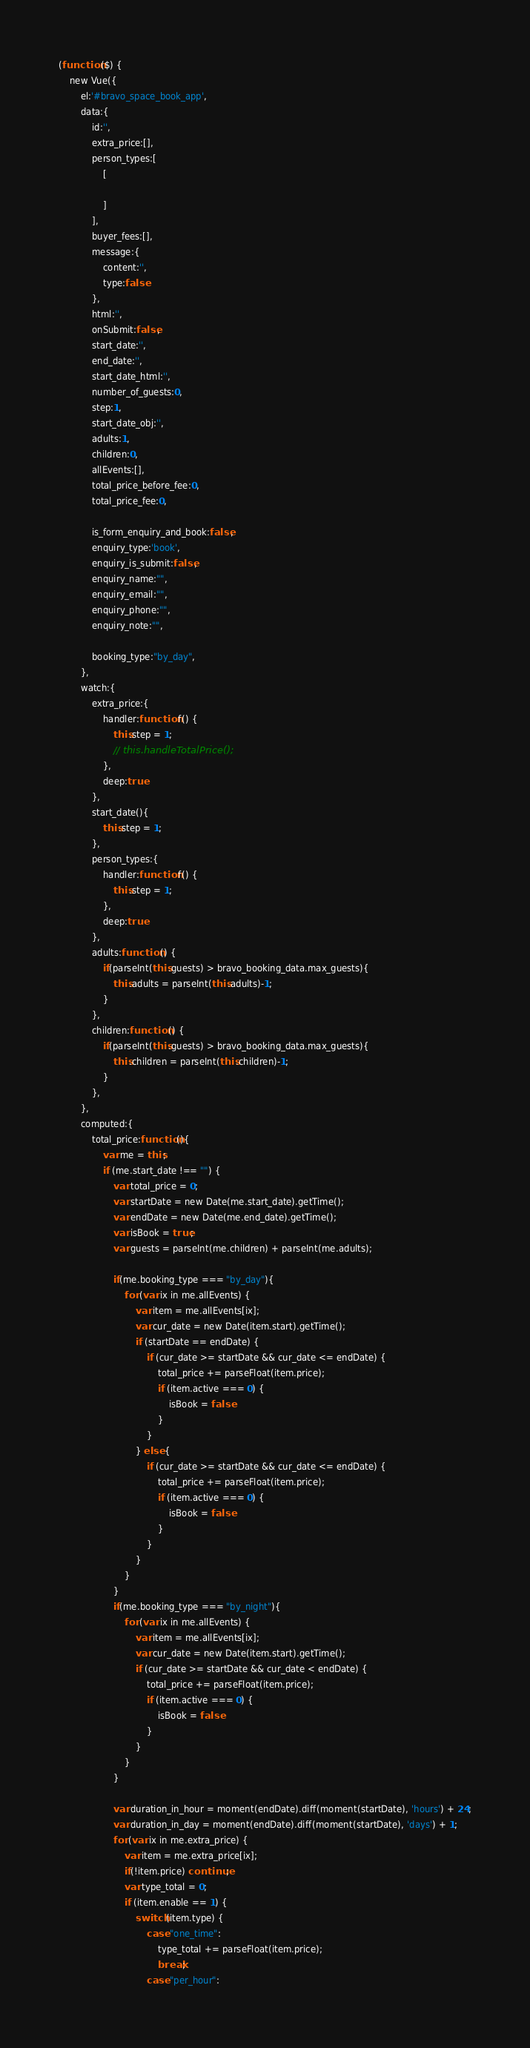Convert code to text. <code><loc_0><loc_0><loc_500><loc_500><_JavaScript_>(function ($) {
    new Vue({
        el:'#bravo_space_book_app',
        data:{
            id:'',
            extra_price:[],
            person_types:[
                [

                ]
            ],
            buyer_fees:[],
            message:{
                content:'',
                type:false
            },
            html:'',
            onSubmit:false,
            start_date:'',
            end_date:'',
            start_date_html:'',
            number_of_guests:0,
            step:1,
            start_date_obj:'',
            adults:1,
            children:0,
            allEvents:[],
            total_price_before_fee:0,
            total_price_fee:0,

            is_form_enquiry_and_book:false,
            enquiry_type:'book',
            enquiry_is_submit:false,
            enquiry_name:"",
            enquiry_email:"",
            enquiry_phone:"",
            enquiry_note:"",

            booking_type:"by_day",
        },
        watch:{
            extra_price:{
                handler:function f() {
                    this.step = 1;
                    // this.handleTotalPrice();
                },
                deep:true
            },
            start_date(){
                this.step = 1;
            },
            person_types:{
                handler:function f() {
                    this.step = 1;
                },
                deep:true
            },
            adults:function () {
                if(parseInt(this.guests) > bravo_booking_data.max_guests){
                    this.adults = parseInt(this.adults)-1;
                }
            },
            children:function () {
                if(parseInt(this.guests) > bravo_booking_data.max_guests){
                    this.children = parseInt(this.children)-1;
                }
            },
        },
        computed:{
            total_price:function(){
                var me = this;
                if (me.start_date !== "") {
                    var total_price = 0;
                    var startDate = new Date(me.start_date).getTime();
                    var endDate = new Date(me.end_date).getTime();
                    var isBook = true;
                    var guests = parseInt(me.children) + parseInt(me.adults);

                    if(me.booking_type === "by_day"){
                        for (var ix in me.allEvents) {
                            var item = me.allEvents[ix];
                            var cur_date = new Date(item.start).getTime();
                            if (startDate == endDate) {
                                if (cur_date >= startDate && cur_date <= endDate) {
                                    total_price += parseFloat(item.price);
                                    if (item.active === 0) {
                                        isBook = false
                                    }
                                }
                            } else {
                                if (cur_date >= startDate && cur_date <= endDate) {
                                    total_price += parseFloat(item.price);
                                    if (item.active === 0) {
                                        isBook = false
                                    }
                                }
                            }
                        }
                    }
                    if(me.booking_type === "by_night"){
                        for (var ix in me.allEvents) {
                            var item = me.allEvents[ix];
                            var cur_date = new Date(item.start).getTime();
                            if (cur_date >= startDate && cur_date < endDate) {
                                total_price += parseFloat(item.price);
                                if (item.active === 0) {
                                    isBook = false
                                }
                            }
                        }
                    }

                    var duration_in_hour = moment(endDate).diff(moment(startDate), 'hours') + 24;
                    var duration_in_day = moment(endDate).diff(moment(startDate), 'days') + 1;
                    for (var ix in me.extra_price) {
                        var item = me.extra_price[ix];
                        if(!item.price) continue;
                        var type_total = 0;
                        if (item.enable == 1) {
                            switch (item.type) {
                                case "one_time":
                                    type_total += parseFloat(item.price);
                                    break;
                                case "per_hour":</code> 